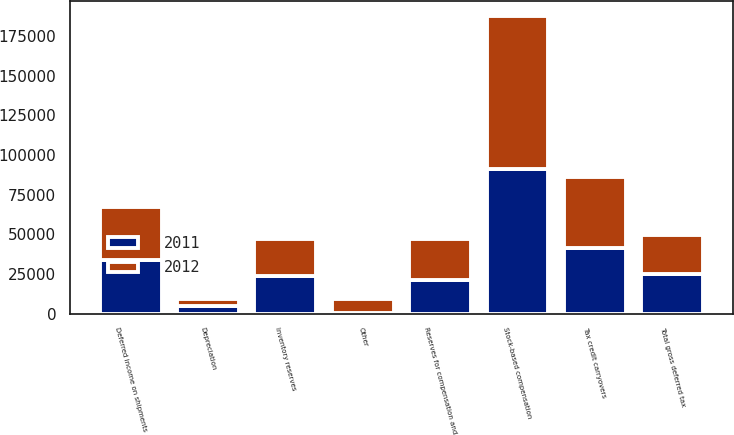<chart> <loc_0><loc_0><loc_500><loc_500><stacked_bar_chart><ecel><fcel>Inventory reserves<fcel>Deferred income on shipments<fcel>Reserves for compensation and<fcel>Tax credit carryovers<fcel>Stock-based compensation<fcel>Depreciation<fcel>Other<fcel>Total gross deferred tax<nl><fcel>2012<fcel>23496<fcel>33236<fcel>26046<fcel>44550<fcel>96140<fcel>4386<fcel>8712<fcel>24774.5<nl><fcel>2011<fcel>23503<fcel>34061<fcel>21164<fcel>41468<fcel>91417<fcel>4781<fcel>592<fcel>24774.5<nl></chart> 